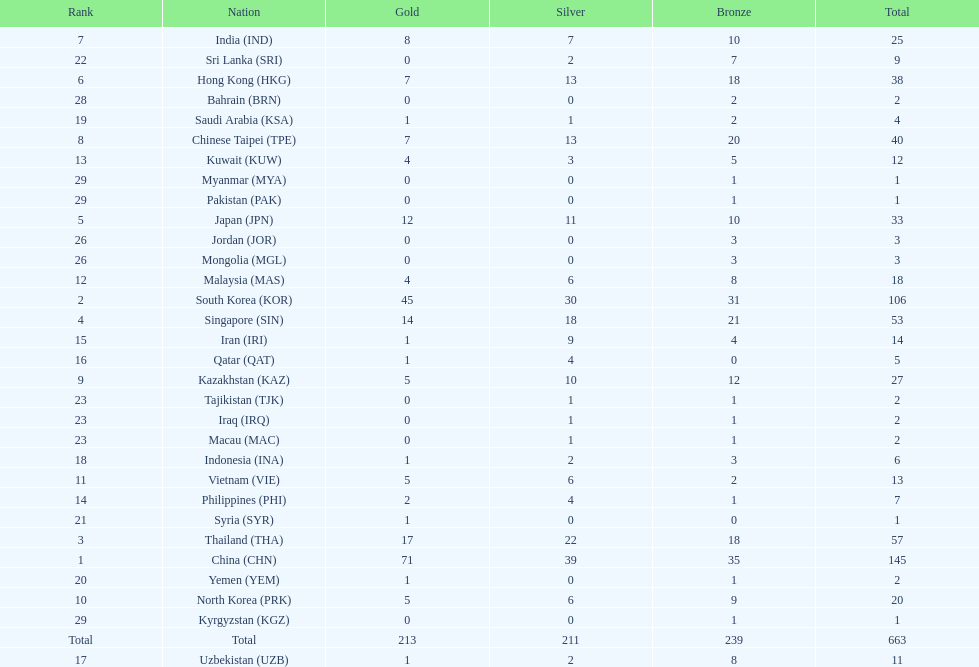What is the difference between the total amount of medals won by qatar and indonesia? 1. 